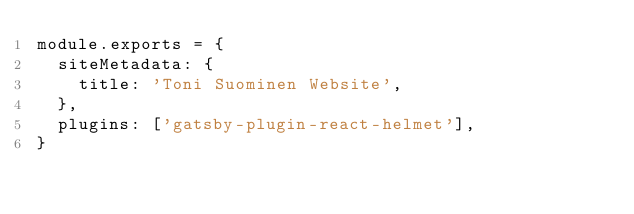Convert code to text. <code><loc_0><loc_0><loc_500><loc_500><_JavaScript_>module.exports = {
  siteMetadata: {
    title: 'Toni Suominen Website',
  },
  plugins: ['gatsby-plugin-react-helmet'],
}
</code> 